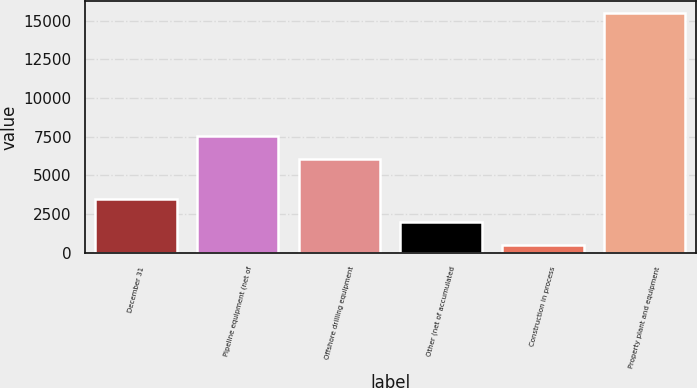Convert chart to OTSL. <chart><loc_0><loc_0><loc_500><loc_500><bar_chart><fcel>December 31<fcel>Pipeline equipment (net of<fcel>Offshore drilling equipment<fcel>Other (net of accumulated<fcel>Construction in process<fcel>Property plant and equipment<nl><fcel>3490.6<fcel>7569.3<fcel>6071<fcel>1992.3<fcel>494<fcel>15477<nl></chart> 